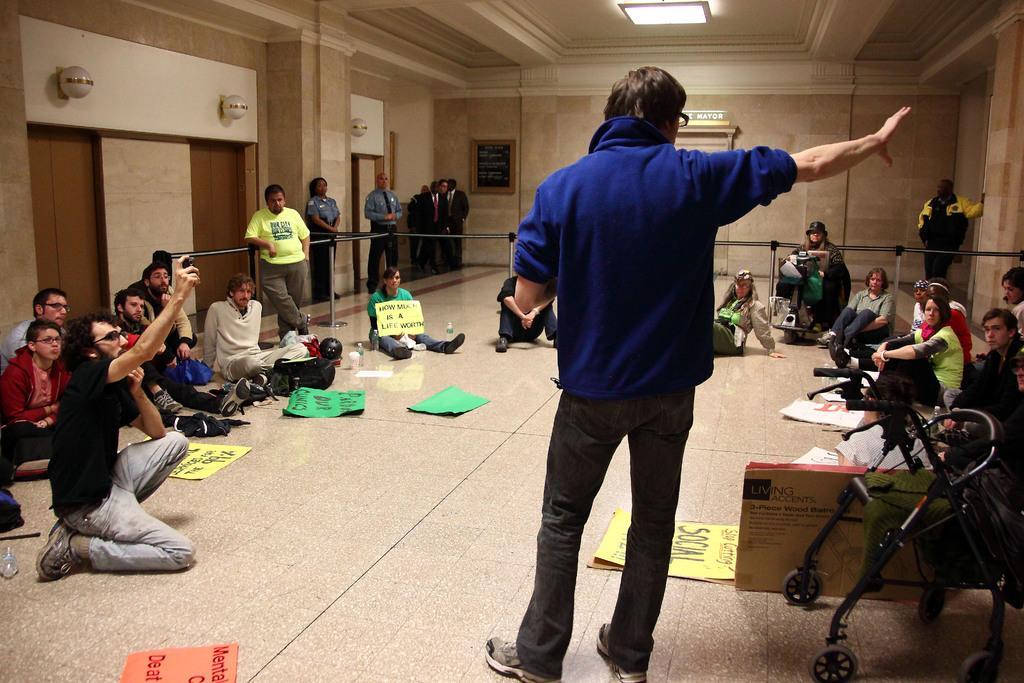Please provide a concise description of this image. On the left side of the image we can see some persons are standing and some persons are sitting. We can also see a person is wearing a black color dress is holding something in his hand and some posters are there on the floor. In the middle of the image we can see a person is standing and he is wearing blue color dress and some persons are sitting on the floor. On the right side of the image we can see some persons are sitting on the floor and some posters are there on the floor. 